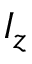Convert formula to latex. <formula><loc_0><loc_0><loc_500><loc_500>I _ { z }</formula> 